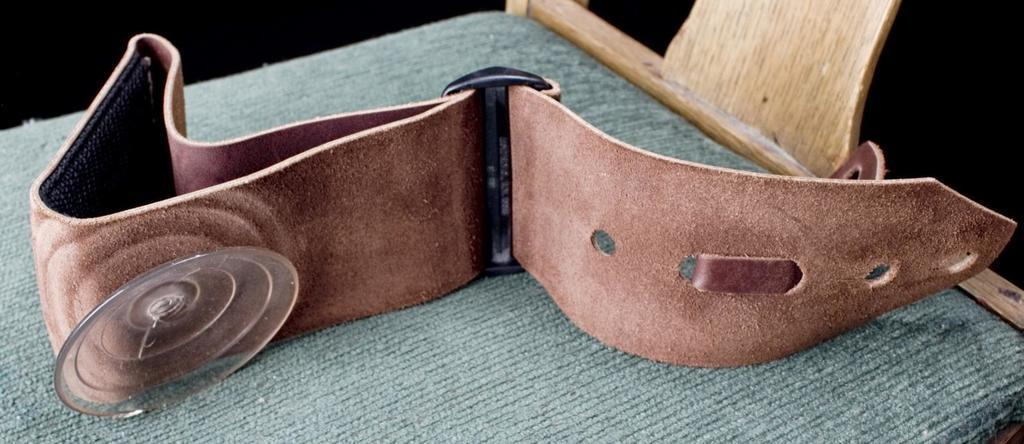What object is present in the image? There is a belt in the image. Where is the belt located? The belt is placed on a chair. How many eyes can be seen on the belt in the image? There are no eyes present on the belt in the image. 